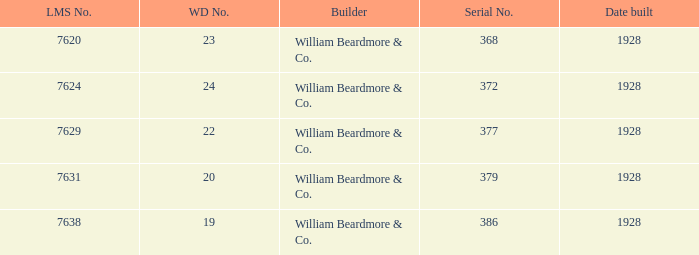Name the lms number for serial number being 372 7624.0. 